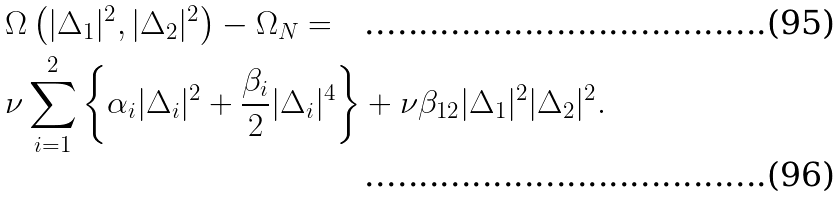<formula> <loc_0><loc_0><loc_500><loc_500>& \Omega \left ( | \Delta _ { 1 } | ^ { 2 } , | \Delta _ { 2 } | ^ { 2 } \right ) - \Omega _ { N } = \\ & \nu \sum _ { i = 1 } ^ { 2 } \left \{ \alpha _ { i } | \Delta _ { i } | ^ { 2 } + \frac { \beta _ { i } } { 2 } | \Delta _ { i } | ^ { 4 } \right \} + \nu \beta _ { 1 2 } | \Delta _ { 1 } | ^ { 2 } | \Delta _ { 2 } | ^ { 2 } .</formula> 